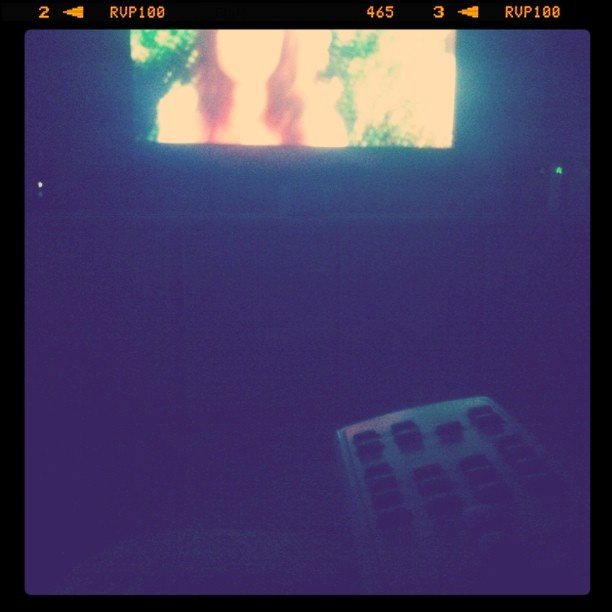Describe the objects in this image and their specific colors. I can see remote in black, navy, darkblue, gray, and purple tones and tv in black, tan, lightpink, lightgreen, and teal tones in this image. 